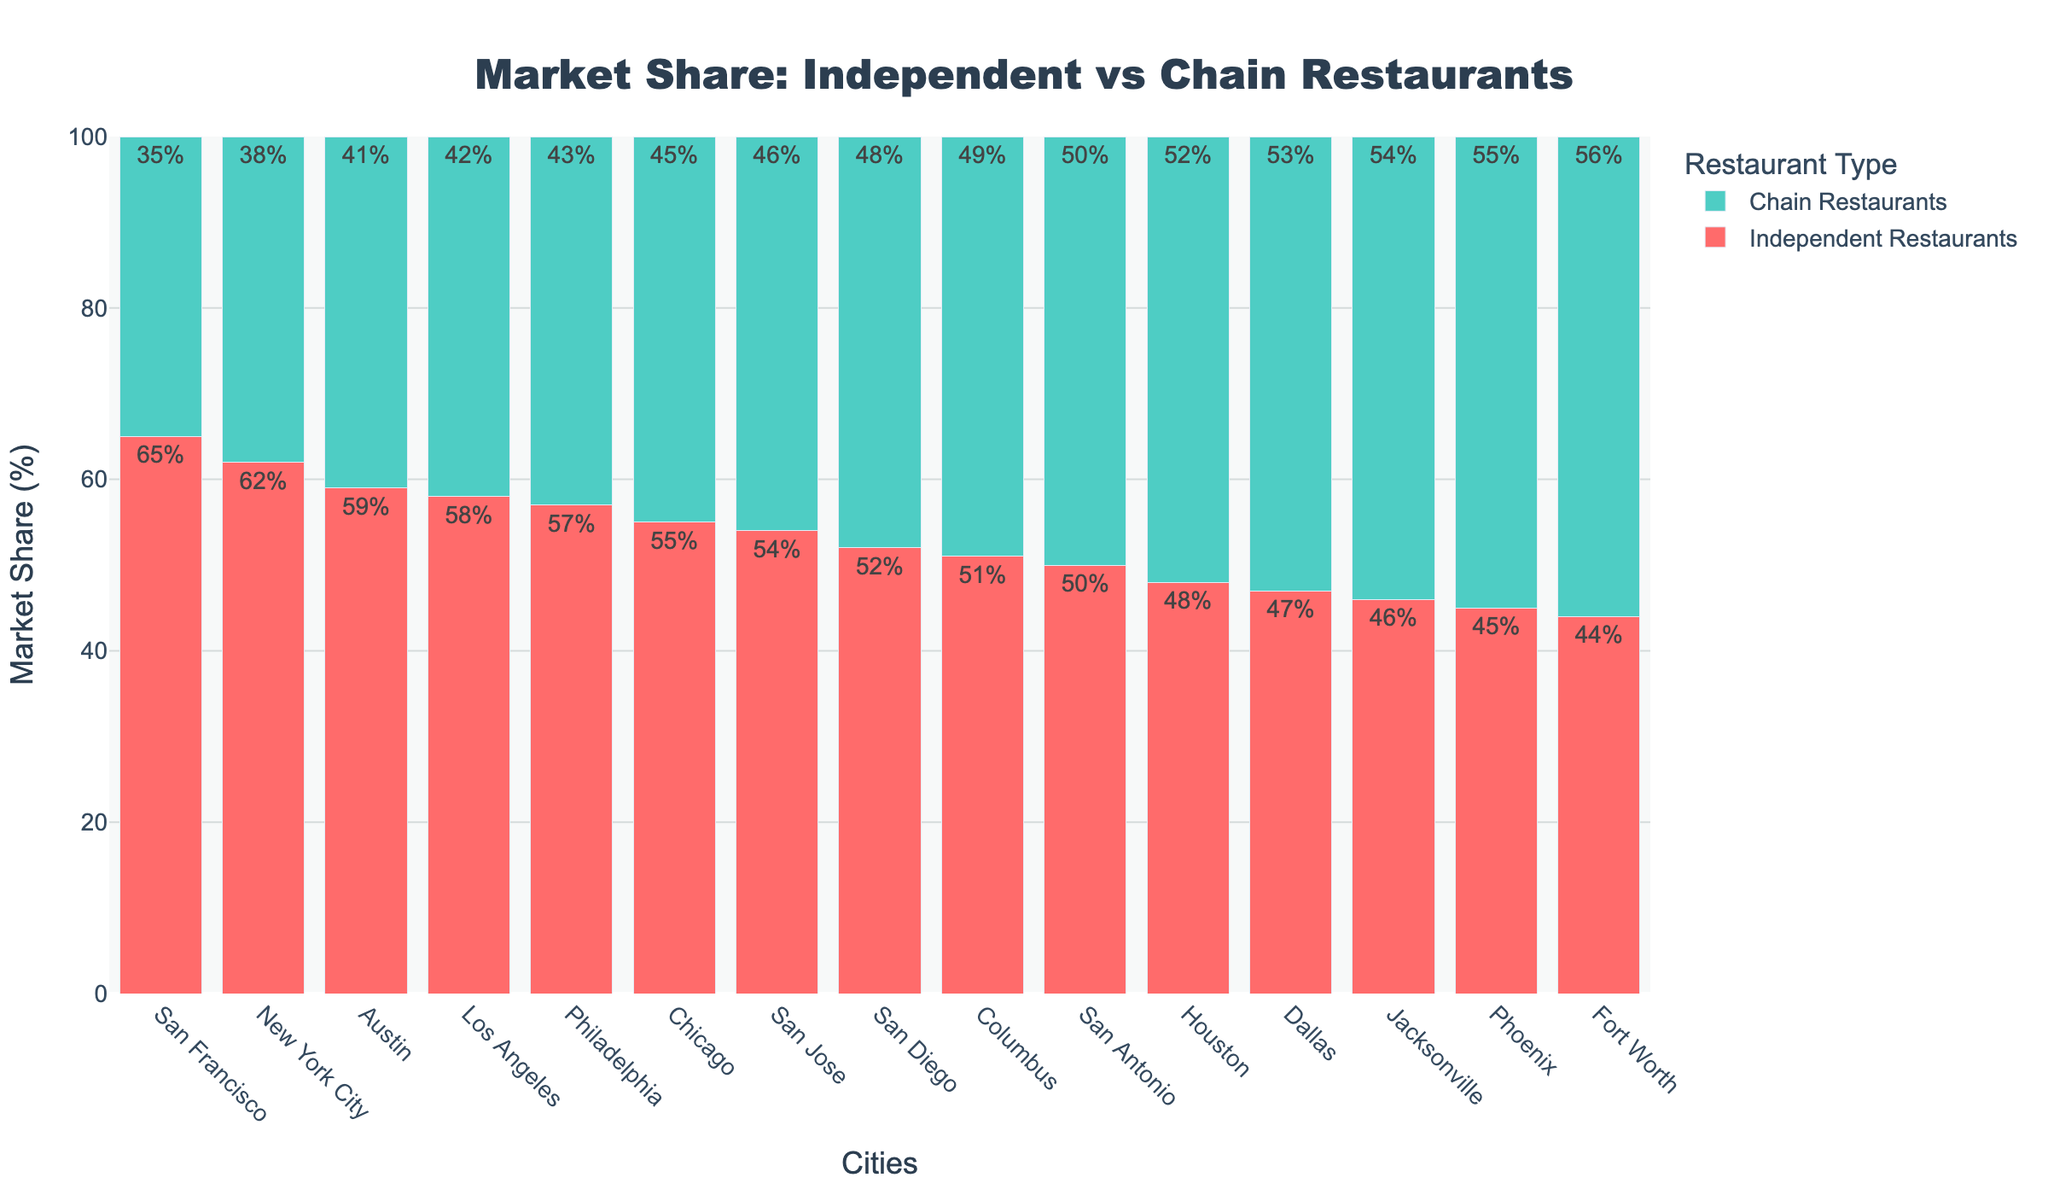Which city has the highest market share of independent restaurants? The city with the highest market share of independent restaurants has the tallest red bar on the chart. Thus, we look for this tallest red bar, which represents 65%.
Answer: San Francisco Which city has a larger market share of chain restaurants, Houston or Dallas? We examine the heights of the green bars for Houston and Dallas. The green bar for Dallas is taller at 53%, compared to Houston's 52%.
Answer: Dallas What is the total market share percentage of independent restaurants in New York City and Los Angeles combined? We add the market share percentages of independent restaurants for New York City (62%) and Los Angeles (58%). The total is 62 + 58 = 120%.
Answer: 120% How do the market share of independent vs. chain restaurants in San Diego compare visually? In the chart, the heights of the red and green bars for San Diego are very close, indicating that their market shares are almost equal. Red bar is at 52% and green at 48%.
Answer: Independent restaurants: 52%, Chain restaurants: 48% Which city has the lowest market share of independent restaurants? The city with the lowest market share of independent restaurants has the shortest red bar on the chart. Fort Worth has the shortest red bar at 44%.
Answer: Fort Worth Compare the total market share of chain restaurants in Philadelphia and Columbus? Which city has a higher total? The market share of chain restaurants in Philadelphia is represented by a green bar at 43%, while Columbus has a green bar at 49%. Therefore, Columbus has a higher total.
Answer: Columbus For which city is the market share of independent and chain restaurants exactly equal? We look for the city where the red and green bars are of equal height. San Antonio has both heights at 50%.
Answer: San Antonio What is the difference in market share percentage of independent restaurants between Austin and Phoenix? We find the independent restaurants' share for Austin (59%) and Phoenix (45%), then subtract the smaller share from the larger share: 59 - 45 = 14%.
Answer: 14% Calculate the average market share percentage of independent restaurants in the top 5 cities with the highest independent restaurant share. We first identify the top 5 cities: San Francisco (65%), New York City (62%), Austin (59%), Los Angeles (58%), and Philadelphia (57%). Then, we calculate the average: (65 + 62 + 59 + 58 + 57) / 5 = 60.2%.
Answer: 60.2% 